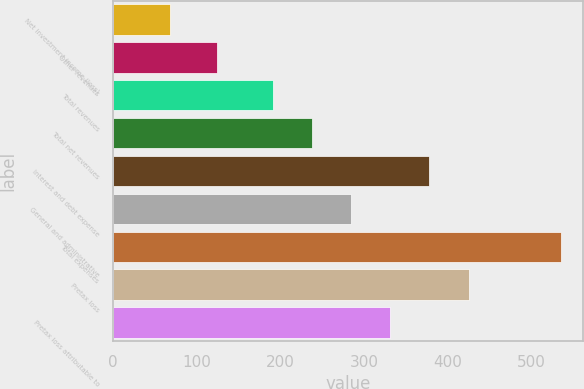Convert chart to OTSL. <chart><loc_0><loc_0><loc_500><loc_500><bar_chart><fcel>Net investment income (loss)<fcel>Other revenues<fcel>Total revenues<fcel>Total net revenues<fcel>Interest and debt expense<fcel>General and administrative<fcel>Total expenses<fcel>Pretax loss<fcel>Pretax loss attributable to<nl><fcel>68<fcel>124<fcel>191<fcel>237.7<fcel>377.8<fcel>284.4<fcel>535<fcel>424.5<fcel>331.1<nl></chart> 